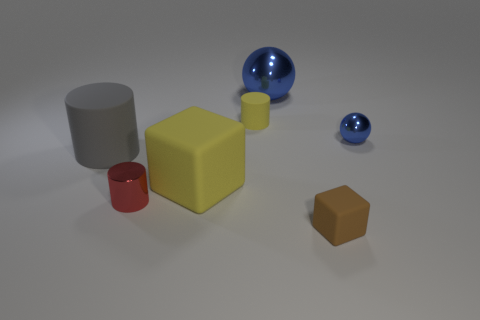Add 2 matte objects. How many objects exist? 9 Subtract all cubes. How many objects are left? 5 Add 6 blue metal things. How many blue metal things are left? 8 Add 1 small gray metallic cylinders. How many small gray metallic cylinders exist? 1 Subtract 0 purple blocks. How many objects are left? 7 Subtract all gray cylinders. Subtract all big yellow rubber objects. How many objects are left? 5 